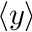<formula> <loc_0><loc_0><loc_500><loc_500>\langle y \rangle</formula> 